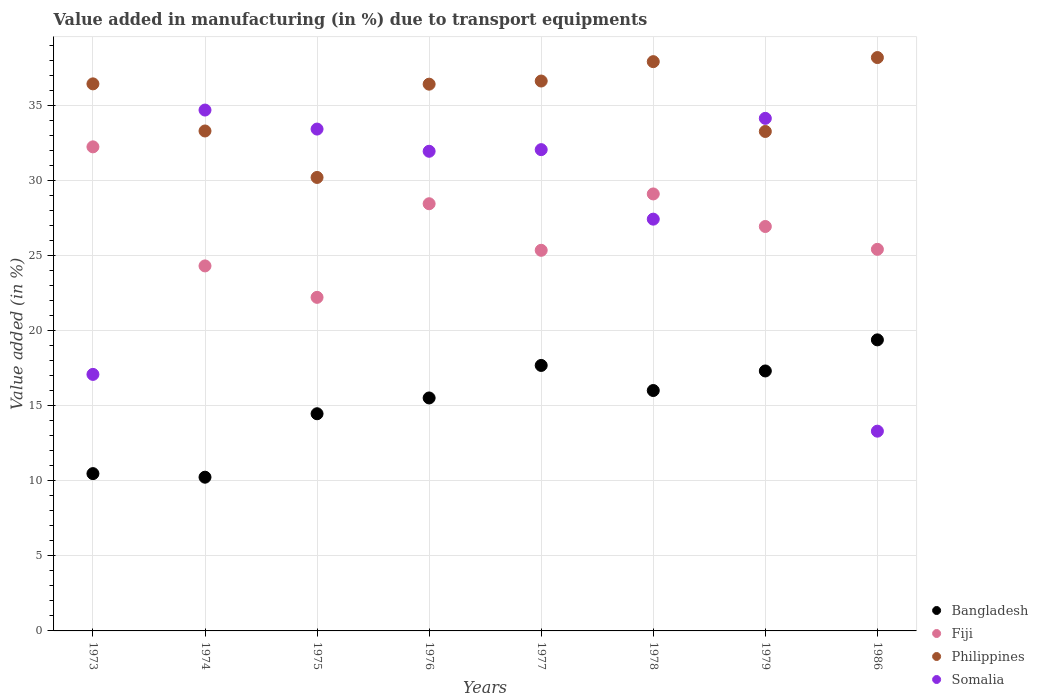How many different coloured dotlines are there?
Provide a succinct answer. 4. Is the number of dotlines equal to the number of legend labels?
Provide a short and direct response. Yes. What is the percentage of value added in manufacturing due to transport equipments in Somalia in 1973?
Your answer should be compact. 17.1. Across all years, what is the maximum percentage of value added in manufacturing due to transport equipments in Somalia?
Your answer should be compact. 34.72. Across all years, what is the minimum percentage of value added in manufacturing due to transport equipments in Philippines?
Provide a succinct answer. 30.23. What is the total percentage of value added in manufacturing due to transport equipments in Fiji in the graph?
Your answer should be compact. 214.19. What is the difference between the percentage of value added in manufacturing due to transport equipments in Somalia in 1973 and that in 1977?
Make the answer very short. -14.98. What is the difference between the percentage of value added in manufacturing due to transport equipments in Somalia in 1975 and the percentage of value added in manufacturing due to transport equipments in Bangladesh in 1976?
Give a very brief answer. 17.92. What is the average percentage of value added in manufacturing due to transport equipments in Philippines per year?
Make the answer very short. 35.32. In the year 1974, what is the difference between the percentage of value added in manufacturing due to transport equipments in Philippines and percentage of value added in manufacturing due to transport equipments in Somalia?
Keep it short and to the point. -1.39. What is the ratio of the percentage of value added in manufacturing due to transport equipments in Somalia in 1975 to that in 1986?
Your answer should be very brief. 2.51. Is the difference between the percentage of value added in manufacturing due to transport equipments in Philippines in 1973 and 1979 greater than the difference between the percentage of value added in manufacturing due to transport equipments in Somalia in 1973 and 1979?
Keep it short and to the point. Yes. What is the difference between the highest and the second highest percentage of value added in manufacturing due to transport equipments in Philippines?
Offer a very short reply. 0.27. What is the difference between the highest and the lowest percentage of value added in manufacturing due to transport equipments in Philippines?
Your response must be concise. 7.99. How many dotlines are there?
Provide a succinct answer. 4. What is the difference between two consecutive major ticks on the Y-axis?
Keep it short and to the point. 5. Are the values on the major ticks of Y-axis written in scientific E-notation?
Your answer should be compact. No. Does the graph contain any zero values?
Offer a terse response. No. Does the graph contain grids?
Your answer should be compact. Yes. Where does the legend appear in the graph?
Provide a short and direct response. Bottom right. How many legend labels are there?
Your response must be concise. 4. How are the legend labels stacked?
Make the answer very short. Vertical. What is the title of the graph?
Your answer should be compact. Value added in manufacturing (in %) due to transport equipments. Does "East Asia (developing only)" appear as one of the legend labels in the graph?
Offer a very short reply. No. What is the label or title of the Y-axis?
Give a very brief answer. Value added (in %). What is the Value added (in %) in Bangladesh in 1973?
Your response must be concise. 10.48. What is the Value added (in %) in Fiji in 1973?
Provide a short and direct response. 32.26. What is the Value added (in %) of Philippines in 1973?
Offer a terse response. 36.46. What is the Value added (in %) in Somalia in 1973?
Make the answer very short. 17.1. What is the Value added (in %) in Bangladesh in 1974?
Offer a terse response. 10.25. What is the Value added (in %) in Fiji in 1974?
Provide a short and direct response. 24.33. What is the Value added (in %) of Philippines in 1974?
Keep it short and to the point. 33.32. What is the Value added (in %) of Somalia in 1974?
Offer a terse response. 34.72. What is the Value added (in %) of Bangladesh in 1975?
Offer a very short reply. 14.48. What is the Value added (in %) in Fiji in 1975?
Your answer should be compact. 22.23. What is the Value added (in %) of Philippines in 1975?
Offer a very short reply. 30.23. What is the Value added (in %) in Somalia in 1975?
Your answer should be very brief. 33.45. What is the Value added (in %) in Bangladesh in 1976?
Make the answer very short. 15.53. What is the Value added (in %) of Fiji in 1976?
Make the answer very short. 28.47. What is the Value added (in %) in Philippines in 1976?
Your answer should be very brief. 36.44. What is the Value added (in %) of Somalia in 1976?
Give a very brief answer. 31.97. What is the Value added (in %) in Bangladesh in 1977?
Your answer should be very brief. 17.7. What is the Value added (in %) of Fiji in 1977?
Provide a short and direct response. 25.37. What is the Value added (in %) of Philippines in 1977?
Keep it short and to the point. 36.65. What is the Value added (in %) of Somalia in 1977?
Make the answer very short. 32.08. What is the Value added (in %) in Bangladesh in 1978?
Ensure brevity in your answer.  16.02. What is the Value added (in %) in Fiji in 1978?
Ensure brevity in your answer.  29.13. What is the Value added (in %) of Philippines in 1978?
Offer a terse response. 37.94. What is the Value added (in %) of Somalia in 1978?
Keep it short and to the point. 27.45. What is the Value added (in %) in Bangladesh in 1979?
Your answer should be compact. 17.33. What is the Value added (in %) of Fiji in 1979?
Your response must be concise. 26.96. What is the Value added (in %) in Philippines in 1979?
Make the answer very short. 33.29. What is the Value added (in %) in Somalia in 1979?
Give a very brief answer. 34.16. What is the Value added (in %) in Bangladesh in 1986?
Ensure brevity in your answer.  19.4. What is the Value added (in %) of Fiji in 1986?
Ensure brevity in your answer.  25.43. What is the Value added (in %) of Philippines in 1986?
Offer a very short reply. 38.22. What is the Value added (in %) in Somalia in 1986?
Offer a terse response. 13.31. Across all years, what is the maximum Value added (in %) of Bangladesh?
Keep it short and to the point. 19.4. Across all years, what is the maximum Value added (in %) in Fiji?
Your answer should be compact. 32.26. Across all years, what is the maximum Value added (in %) in Philippines?
Offer a terse response. 38.22. Across all years, what is the maximum Value added (in %) of Somalia?
Your answer should be compact. 34.72. Across all years, what is the minimum Value added (in %) in Bangladesh?
Your answer should be compact. 10.25. Across all years, what is the minimum Value added (in %) in Fiji?
Ensure brevity in your answer.  22.23. Across all years, what is the minimum Value added (in %) in Philippines?
Give a very brief answer. 30.23. Across all years, what is the minimum Value added (in %) in Somalia?
Offer a terse response. 13.31. What is the total Value added (in %) of Bangladesh in the graph?
Ensure brevity in your answer.  121.18. What is the total Value added (in %) of Fiji in the graph?
Ensure brevity in your answer.  214.19. What is the total Value added (in %) of Philippines in the graph?
Offer a very short reply. 282.56. What is the total Value added (in %) in Somalia in the graph?
Provide a succinct answer. 224.24. What is the difference between the Value added (in %) of Bangladesh in 1973 and that in 1974?
Offer a very short reply. 0.24. What is the difference between the Value added (in %) in Fiji in 1973 and that in 1974?
Keep it short and to the point. 7.94. What is the difference between the Value added (in %) of Philippines in 1973 and that in 1974?
Give a very brief answer. 3.14. What is the difference between the Value added (in %) in Somalia in 1973 and that in 1974?
Keep it short and to the point. -17.62. What is the difference between the Value added (in %) in Bangladesh in 1973 and that in 1975?
Provide a succinct answer. -3.99. What is the difference between the Value added (in %) in Fiji in 1973 and that in 1975?
Provide a succinct answer. 10.03. What is the difference between the Value added (in %) in Philippines in 1973 and that in 1975?
Offer a terse response. 6.24. What is the difference between the Value added (in %) in Somalia in 1973 and that in 1975?
Offer a terse response. -16.35. What is the difference between the Value added (in %) of Bangladesh in 1973 and that in 1976?
Give a very brief answer. -5.04. What is the difference between the Value added (in %) in Fiji in 1973 and that in 1976?
Make the answer very short. 3.79. What is the difference between the Value added (in %) of Philippines in 1973 and that in 1976?
Provide a short and direct response. 0.02. What is the difference between the Value added (in %) in Somalia in 1973 and that in 1976?
Your answer should be compact. -14.87. What is the difference between the Value added (in %) in Bangladesh in 1973 and that in 1977?
Offer a very short reply. -7.21. What is the difference between the Value added (in %) of Fiji in 1973 and that in 1977?
Ensure brevity in your answer.  6.9. What is the difference between the Value added (in %) in Philippines in 1973 and that in 1977?
Offer a very short reply. -0.19. What is the difference between the Value added (in %) of Somalia in 1973 and that in 1977?
Keep it short and to the point. -14.98. What is the difference between the Value added (in %) in Bangladesh in 1973 and that in 1978?
Make the answer very short. -5.54. What is the difference between the Value added (in %) of Fiji in 1973 and that in 1978?
Give a very brief answer. 3.14. What is the difference between the Value added (in %) in Philippines in 1973 and that in 1978?
Your answer should be very brief. -1.48. What is the difference between the Value added (in %) in Somalia in 1973 and that in 1978?
Your answer should be compact. -10.35. What is the difference between the Value added (in %) of Bangladesh in 1973 and that in 1979?
Keep it short and to the point. -6.84. What is the difference between the Value added (in %) of Fiji in 1973 and that in 1979?
Keep it short and to the point. 5.31. What is the difference between the Value added (in %) of Philippines in 1973 and that in 1979?
Your answer should be very brief. 3.17. What is the difference between the Value added (in %) of Somalia in 1973 and that in 1979?
Keep it short and to the point. -17.07. What is the difference between the Value added (in %) in Bangladesh in 1973 and that in 1986?
Offer a very short reply. -8.92. What is the difference between the Value added (in %) of Fiji in 1973 and that in 1986?
Offer a very short reply. 6.83. What is the difference between the Value added (in %) in Philippines in 1973 and that in 1986?
Provide a short and direct response. -1.75. What is the difference between the Value added (in %) in Somalia in 1973 and that in 1986?
Your answer should be very brief. 3.78. What is the difference between the Value added (in %) of Bangladesh in 1974 and that in 1975?
Give a very brief answer. -4.23. What is the difference between the Value added (in %) of Fiji in 1974 and that in 1975?
Offer a very short reply. 2.1. What is the difference between the Value added (in %) of Philippines in 1974 and that in 1975?
Provide a short and direct response. 3.1. What is the difference between the Value added (in %) of Somalia in 1974 and that in 1975?
Provide a succinct answer. 1.27. What is the difference between the Value added (in %) in Bangladesh in 1974 and that in 1976?
Give a very brief answer. -5.28. What is the difference between the Value added (in %) in Fiji in 1974 and that in 1976?
Provide a succinct answer. -4.14. What is the difference between the Value added (in %) of Philippines in 1974 and that in 1976?
Make the answer very short. -3.12. What is the difference between the Value added (in %) in Somalia in 1974 and that in 1976?
Keep it short and to the point. 2.75. What is the difference between the Value added (in %) in Bangladesh in 1974 and that in 1977?
Keep it short and to the point. -7.45. What is the difference between the Value added (in %) in Fiji in 1974 and that in 1977?
Your answer should be very brief. -1.04. What is the difference between the Value added (in %) of Philippines in 1974 and that in 1977?
Your answer should be very brief. -3.33. What is the difference between the Value added (in %) in Somalia in 1974 and that in 1977?
Offer a very short reply. 2.64. What is the difference between the Value added (in %) in Bangladesh in 1974 and that in 1978?
Give a very brief answer. -5.78. What is the difference between the Value added (in %) in Fiji in 1974 and that in 1978?
Give a very brief answer. -4.8. What is the difference between the Value added (in %) of Philippines in 1974 and that in 1978?
Keep it short and to the point. -4.62. What is the difference between the Value added (in %) of Somalia in 1974 and that in 1978?
Your answer should be very brief. 7.27. What is the difference between the Value added (in %) in Bangladesh in 1974 and that in 1979?
Your answer should be compact. -7.08. What is the difference between the Value added (in %) in Fiji in 1974 and that in 1979?
Ensure brevity in your answer.  -2.63. What is the difference between the Value added (in %) in Philippines in 1974 and that in 1979?
Offer a very short reply. 0.03. What is the difference between the Value added (in %) in Somalia in 1974 and that in 1979?
Your answer should be very brief. 0.55. What is the difference between the Value added (in %) of Bangladesh in 1974 and that in 1986?
Your answer should be compact. -9.15. What is the difference between the Value added (in %) of Fiji in 1974 and that in 1986?
Your answer should be compact. -1.11. What is the difference between the Value added (in %) in Philippines in 1974 and that in 1986?
Your response must be concise. -4.89. What is the difference between the Value added (in %) in Somalia in 1974 and that in 1986?
Offer a terse response. 21.4. What is the difference between the Value added (in %) in Bangladesh in 1975 and that in 1976?
Give a very brief answer. -1.05. What is the difference between the Value added (in %) in Fiji in 1975 and that in 1976?
Ensure brevity in your answer.  -6.24. What is the difference between the Value added (in %) of Philippines in 1975 and that in 1976?
Offer a very short reply. -6.22. What is the difference between the Value added (in %) in Somalia in 1975 and that in 1976?
Provide a succinct answer. 1.48. What is the difference between the Value added (in %) in Bangladesh in 1975 and that in 1977?
Ensure brevity in your answer.  -3.22. What is the difference between the Value added (in %) of Fiji in 1975 and that in 1977?
Provide a succinct answer. -3.14. What is the difference between the Value added (in %) in Philippines in 1975 and that in 1977?
Give a very brief answer. -6.43. What is the difference between the Value added (in %) of Somalia in 1975 and that in 1977?
Offer a very short reply. 1.37. What is the difference between the Value added (in %) in Bangladesh in 1975 and that in 1978?
Ensure brevity in your answer.  -1.55. What is the difference between the Value added (in %) in Fiji in 1975 and that in 1978?
Ensure brevity in your answer.  -6.89. What is the difference between the Value added (in %) of Philippines in 1975 and that in 1978?
Your response must be concise. -7.72. What is the difference between the Value added (in %) of Somalia in 1975 and that in 1978?
Give a very brief answer. 6. What is the difference between the Value added (in %) of Bangladesh in 1975 and that in 1979?
Provide a short and direct response. -2.85. What is the difference between the Value added (in %) in Fiji in 1975 and that in 1979?
Provide a succinct answer. -4.72. What is the difference between the Value added (in %) of Philippines in 1975 and that in 1979?
Your answer should be very brief. -3.06. What is the difference between the Value added (in %) in Somalia in 1975 and that in 1979?
Ensure brevity in your answer.  -0.71. What is the difference between the Value added (in %) of Bangladesh in 1975 and that in 1986?
Your answer should be compact. -4.92. What is the difference between the Value added (in %) in Fiji in 1975 and that in 1986?
Make the answer very short. -3.2. What is the difference between the Value added (in %) in Philippines in 1975 and that in 1986?
Keep it short and to the point. -7.99. What is the difference between the Value added (in %) in Somalia in 1975 and that in 1986?
Your answer should be compact. 20.14. What is the difference between the Value added (in %) in Bangladesh in 1976 and that in 1977?
Keep it short and to the point. -2.17. What is the difference between the Value added (in %) of Fiji in 1976 and that in 1977?
Give a very brief answer. 3.1. What is the difference between the Value added (in %) of Philippines in 1976 and that in 1977?
Your answer should be very brief. -0.21. What is the difference between the Value added (in %) of Somalia in 1976 and that in 1977?
Provide a succinct answer. -0.11. What is the difference between the Value added (in %) in Bangladesh in 1976 and that in 1978?
Your response must be concise. -0.5. What is the difference between the Value added (in %) of Fiji in 1976 and that in 1978?
Give a very brief answer. -0.65. What is the difference between the Value added (in %) of Philippines in 1976 and that in 1978?
Provide a succinct answer. -1.5. What is the difference between the Value added (in %) in Somalia in 1976 and that in 1978?
Provide a short and direct response. 4.52. What is the difference between the Value added (in %) in Bangladesh in 1976 and that in 1979?
Make the answer very short. -1.8. What is the difference between the Value added (in %) in Fiji in 1976 and that in 1979?
Give a very brief answer. 1.52. What is the difference between the Value added (in %) of Philippines in 1976 and that in 1979?
Give a very brief answer. 3.15. What is the difference between the Value added (in %) in Somalia in 1976 and that in 1979?
Offer a terse response. -2.19. What is the difference between the Value added (in %) in Bangladesh in 1976 and that in 1986?
Offer a terse response. -3.87. What is the difference between the Value added (in %) in Fiji in 1976 and that in 1986?
Ensure brevity in your answer.  3.04. What is the difference between the Value added (in %) in Philippines in 1976 and that in 1986?
Keep it short and to the point. -1.77. What is the difference between the Value added (in %) in Somalia in 1976 and that in 1986?
Offer a terse response. 18.66. What is the difference between the Value added (in %) of Bangladesh in 1977 and that in 1978?
Your answer should be compact. 1.67. What is the difference between the Value added (in %) of Fiji in 1977 and that in 1978?
Keep it short and to the point. -3.76. What is the difference between the Value added (in %) of Philippines in 1977 and that in 1978?
Make the answer very short. -1.29. What is the difference between the Value added (in %) of Somalia in 1977 and that in 1978?
Keep it short and to the point. 4.63. What is the difference between the Value added (in %) in Bangladesh in 1977 and that in 1979?
Ensure brevity in your answer.  0.37. What is the difference between the Value added (in %) of Fiji in 1977 and that in 1979?
Offer a terse response. -1.59. What is the difference between the Value added (in %) of Philippines in 1977 and that in 1979?
Offer a very short reply. 3.36. What is the difference between the Value added (in %) in Somalia in 1977 and that in 1979?
Provide a short and direct response. -2.09. What is the difference between the Value added (in %) of Bangladesh in 1977 and that in 1986?
Your response must be concise. -1.7. What is the difference between the Value added (in %) of Fiji in 1977 and that in 1986?
Give a very brief answer. -0.07. What is the difference between the Value added (in %) in Philippines in 1977 and that in 1986?
Your answer should be very brief. -1.56. What is the difference between the Value added (in %) of Somalia in 1977 and that in 1986?
Give a very brief answer. 18.77. What is the difference between the Value added (in %) in Bangladesh in 1978 and that in 1979?
Your answer should be compact. -1.3. What is the difference between the Value added (in %) in Fiji in 1978 and that in 1979?
Your answer should be very brief. 2.17. What is the difference between the Value added (in %) of Philippines in 1978 and that in 1979?
Ensure brevity in your answer.  4.65. What is the difference between the Value added (in %) of Somalia in 1978 and that in 1979?
Your answer should be compact. -6.72. What is the difference between the Value added (in %) in Bangladesh in 1978 and that in 1986?
Your answer should be compact. -3.38. What is the difference between the Value added (in %) in Fiji in 1978 and that in 1986?
Make the answer very short. 3.69. What is the difference between the Value added (in %) in Philippines in 1978 and that in 1986?
Your answer should be compact. -0.27. What is the difference between the Value added (in %) of Somalia in 1978 and that in 1986?
Ensure brevity in your answer.  14.13. What is the difference between the Value added (in %) of Bangladesh in 1979 and that in 1986?
Your response must be concise. -2.07. What is the difference between the Value added (in %) of Fiji in 1979 and that in 1986?
Offer a very short reply. 1.52. What is the difference between the Value added (in %) of Philippines in 1979 and that in 1986?
Offer a very short reply. -4.93. What is the difference between the Value added (in %) in Somalia in 1979 and that in 1986?
Provide a short and direct response. 20.85. What is the difference between the Value added (in %) in Bangladesh in 1973 and the Value added (in %) in Fiji in 1974?
Your response must be concise. -13.84. What is the difference between the Value added (in %) in Bangladesh in 1973 and the Value added (in %) in Philippines in 1974?
Provide a short and direct response. -22.84. What is the difference between the Value added (in %) of Bangladesh in 1973 and the Value added (in %) of Somalia in 1974?
Ensure brevity in your answer.  -24.23. What is the difference between the Value added (in %) of Fiji in 1973 and the Value added (in %) of Philippines in 1974?
Offer a terse response. -1.06. What is the difference between the Value added (in %) of Fiji in 1973 and the Value added (in %) of Somalia in 1974?
Keep it short and to the point. -2.45. What is the difference between the Value added (in %) in Philippines in 1973 and the Value added (in %) in Somalia in 1974?
Offer a very short reply. 1.75. What is the difference between the Value added (in %) of Bangladesh in 1973 and the Value added (in %) of Fiji in 1975?
Offer a terse response. -11.75. What is the difference between the Value added (in %) in Bangladesh in 1973 and the Value added (in %) in Philippines in 1975?
Offer a terse response. -19.74. What is the difference between the Value added (in %) in Bangladesh in 1973 and the Value added (in %) in Somalia in 1975?
Ensure brevity in your answer.  -22.97. What is the difference between the Value added (in %) in Fiji in 1973 and the Value added (in %) in Philippines in 1975?
Provide a succinct answer. 2.04. What is the difference between the Value added (in %) in Fiji in 1973 and the Value added (in %) in Somalia in 1975?
Keep it short and to the point. -1.19. What is the difference between the Value added (in %) of Philippines in 1973 and the Value added (in %) of Somalia in 1975?
Your answer should be compact. 3.01. What is the difference between the Value added (in %) of Bangladesh in 1973 and the Value added (in %) of Fiji in 1976?
Keep it short and to the point. -17.99. What is the difference between the Value added (in %) in Bangladesh in 1973 and the Value added (in %) in Philippines in 1976?
Your answer should be very brief. -25.96. What is the difference between the Value added (in %) in Bangladesh in 1973 and the Value added (in %) in Somalia in 1976?
Your response must be concise. -21.49. What is the difference between the Value added (in %) of Fiji in 1973 and the Value added (in %) of Philippines in 1976?
Ensure brevity in your answer.  -4.18. What is the difference between the Value added (in %) in Fiji in 1973 and the Value added (in %) in Somalia in 1976?
Your response must be concise. 0.29. What is the difference between the Value added (in %) of Philippines in 1973 and the Value added (in %) of Somalia in 1976?
Ensure brevity in your answer.  4.49. What is the difference between the Value added (in %) of Bangladesh in 1973 and the Value added (in %) of Fiji in 1977?
Offer a terse response. -14.88. What is the difference between the Value added (in %) in Bangladesh in 1973 and the Value added (in %) in Philippines in 1977?
Offer a very short reply. -26.17. What is the difference between the Value added (in %) of Bangladesh in 1973 and the Value added (in %) of Somalia in 1977?
Your answer should be very brief. -21.59. What is the difference between the Value added (in %) of Fiji in 1973 and the Value added (in %) of Philippines in 1977?
Your answer should be very brief. -4.39. What is the difference between the Value added (in %) of Fiji in 1973 and the Value added (in %) of Somalia in 1977?
Your response must be concise. 0.19. What is the difference between the Value added (in %) of Philippines in 1973 and the Value added (in %) of Somalia in 1977?
Offer a terse response. 4.38. What is the difference between the Value added (in %) of Bangladesh in 1973 and the Value added (in %) of Fiji in 1978?
Provide a short and direct response. -18.64. What is the difference between the Value added (in %) in Bangladesh in 1973 and the Value added (in %) in Philippines in 1978?
Keep it short and to the point. -27.46. What is the difference between the Value added (in %) of Bangladesh in 1973 and the Value added (in %) of Somalia in 1978?
Your answer should be very brief. -16.96. What is the difference between the Value added (in %) of Fiji in 1973 and the Value added (in %) of Philippines in 1978?
Ensure brevity in your answer.  -5.68. What is the difference between the Value added (in %) of Fiji in 1973 and the Value added (in %) of Somalia in 1978?
Give a very brief answer. 4.82. What is the difference between the Value added (in %) in Philippines in 1973 and the Value added (in %) in Somalia in 1978?
Provide a short and direct response. 9.02. What is the difference between the Value added (in %) of Bangladesh in 1973 and the Value added (in %) of Fiji in 1979?
Your response must be concise. -16.47. What is the difference between the Value added (in %) of Bangladesh in 1973 and the Value added (in %) of Philippines in 1979?
Offer a terse response. -22.81. What is the difference between the Value added (in %) of Bangladesh in 1973 and the Value added (in %) of Somalia in 1979?
Make the answer very short. -23.68. What is the difference between the Value added (in %) in Fiji in 1973 and the Value added (in %) in Philippines in 1979?
Ensure brevity in your answer.  -1.03. What is the difference between the Value added (in %) in Fiji in 1973 and the Value added (in %) in Somalia in 1979?
Keep it short and to the point. -1.9. What is the difference between the Value added (in %) in Philippines in 1973 and the Value added (in %) in Somalia in 1979?
Keep it short and to the point. 2.3. What is the difference between the Value added (in %) of Bangladesh in 1973 and the Value added (in %) of Fiji in 1986?
Your answer should be very brief. -14.95. What is the difference between the Value added (in %) of Bangladesh in 1973 and the Value added (in %) of Philippines in 1986?
Offer a very short reply. -27.73. What is the difference between the Value added (in %) in Bangladesh in 1973 and the Value added (in %) in Somalia in 1986?
Ensure brevity in your answer.  -2.83. What is the difference between the Value added (in %) of Fiji in 1973 and the Value added (in %) of Philippines in 1986?
Ensure brevity in your answer.  -5.95. What is the difference between the Value added (in %) in Fiji in 1973 and the Value added (in %) in Somalia in 1986?
Provide a short and direct response. 18.95. What is the difference between the Value added (in %) in Philippines in 1973 and the Value added (in %) in Somalia in 1986?
Give a very brief answer. 23.15. What is the difference between the Value added (in %) of Bangladesh in 1974 and the Value added (in %) of Fiji in 1975?
Your response must be concise. -11.99. What is the difference between the Value added (in %) in Bangladesh in 1974 and the Value added (in %) in Philippines in 1975?
Make the answer very short. -19.98. What is the difference between the Value added (in %) in Bangladesh in 1974 and the Value added (in %) in Somalia in 1975?
Keep it short and to the point. -23.2. What is the difference between the Value added (in %) of Fiji in 1974 and the Value added (in %) of Philippines in 1975?
Offer a terse response. -5.9. What is the difference between the Value added (in %) in Fiji in 1974 and the Value added (in %) in Somalia in 1975?
Offer a terse response. -9.12. What is the difference between the Value added (in %) of Philippines in 1974 and the Value added (in %) of Somalia in 1975?
Offer a very short reply. -0.13. What is the difference between the Value added (in %) in Bangladesh in 1974 and the Value added (in %) in Fiji in 1976?
Keep it short and to the point. -18.23. What is the difference between the Value added (in %) in Bangladesh in 1974 and the Value added (in %) in Philippines in 1976?
Make the answer very short. -26.2. What is the difference between the Value added (in %) of Bangladesh in 1974 and the Value added (in %) of Somalia in 1976?
Your answer should be compact. -21.72. What is the difference between the Value added (in %) of Fiji in 1974 and the Value added (in %) of Philippines in 1976?
Give a very brief answer. -12.11. What is the difference between the Value added (in %) in Fiji in 1974 and the Value added (in %) in Somalia in 1976?
Your response must be concise. -7.64. What is the difference between the Value added (in %) in Philippines in 1974 and the Value added (in %) in Somalia in 1976?
Provide a succinct answer. 1.35. What is the difference between the Value added (in %) of Bangladesh in 1974 and the Value added (in %) of Fiji in 1977?
Your answer should be compact. -15.12. What is the difference between the Value added (in %) in Bangladesh in 1974 and the Value added (in %) in Philippines in 1977?
Ensure brevity in your answer.  -26.41. What is the difference between the Value added (in %) in Bangladesh in 1974 and the Value added (in %) in Somalia in 1977?
Make the answer very short. -21.83. What is the difference between the Value added (in %) of Fiji in 1974 and the Value added (in %) of Philippines in 1977?
Ensure brevity in your answer.  -12.32. What is the difference between the Value added (in %) of Fiji in 1974 and the Value added (in %) of Somalia in 1977?
Your response must be concise. -7.75. What is the difference between the Value added (in %) in Philippines in 1974 and the Value added (in %) in Somalia in 1977?
Offer a very short reply. 1.24. What is the difference between the Value added (in %) in Bangladesh in 1974 and the Value added (in %) in Fiji in 1978?
Make the answer very short. -18.88. What is the difference between the Value added (in %) in Bangladesh in 1974 and the Value added (in %) in Philippines in 1978?
Ensure brevity in your answer.  -27.7. What is the difference between the Value added (in %) of Bangladesh in 1974 and the Value added (in %) of Somalia in 1978?
Your answer should be very brief. -17.2. What is the difference between the Value added (in %) in Fiji in 1974 and the Value added (in %) in Philippines in 1978?
Make the answer very short. -13.61. What is the difference between the Value added (in %) in Fiji in 1974 and the Value added (in %) in Somalia in 1978?
Provide a succinct answer. -3.12. What is the difference between the Value added (in %) of Philippines in 1974 and the Value added (in %) of Somalia in 1978?
Your response must be concise. 5.88. What is the difference between the Value added (in %) in Bangladesh in 1974 and the Value added (in %) in Fiji in 1979?
Keep it short and to the point. -16.71. What is the difference between the Value added (in %) in Bangladesh in 1974 and the Value added (in %) in Philippines in 1979?
Your answer should be compact. -23.04. What is the difference between the Value added (in %) in Bangladesh in 1974 and the Value added (in %) in Somalia in 1979?
Offer a terse response. -23.92. What is the difference between the Value added (in %) of Fiji in 1974 and the Value added (in %) of Philippines in 1979?
Make the answer very short. -8.96. What is the difference between the Value added (in %) in Fiji in 1974 and the Value added (in %) in Somalia in 1979?
Ensure brevity in your answer.  -9.84. What is the difference between the Value added (in %) in Philippines in 1974 and the Value added (in %) in Somalia in 1979?
Offer a terse response. -0.84. What is the difference between the Value added (in %) in Bangladesh in 1974 and the Value added (in %) in Fiji in 1986?
Provide a short and direct response. -15.19. What is the difference between the Value added (in %) in Bangladesh in 1974 and the Value added (in %) in Philippines in 1986?
Provide a short and direct response. -27.97. What is the difference between the Value added (in %) of Bangladesh in 1974 and the Value added (in %) of Somalia in 1986?
Offer a very short reply. -3.07. What is the difference between the Value added (in %) in Fiji in 1974 and the Value added (in %) in Philippines in 1986?
Your answer should be compact. -13.89. What is the difference between the Value added (in %) in Fiji in 1974 and the Value added (in %) in Somalia in 1986?
Give a very brief answer. 11.02. What is the difference between the Value added (in %) in Philippines in 1974 and the Value added (in %) in Somalia in 1986?
Your answer should be very brief. 20.01. What is the difference between the Value added (in %) in Bangladesh in 1975 and the Value added (in %) in Fiji in 1976?
Provide a short and direct response. -14. What is the difference between the Value added (in %) in Bangladesh in 1975 and the Value added (in %) in Philippines in 1976?
Offer a terse response. -21.97. What is the difference between the Value added (in %) in Bangladesh in 1975 and the Value added (in %) in Somalia in 1976?
Make the answer very short. -17.49. What is the difference between the Value added (in %) of Fiji in 1975 and the Value added (in %) of Philippines in 1976?
Provide a short and direct response. -14.21. What is the difference between the Value added (in %) of Fiji in 1975 and the Value added (in %) of Somalia in 1976?
Offer a very short reply. -9.74. What is the difference between the Value added (in %) in Philippines in 1975 and the Value added (in %) in Somalia in 1976?
Give a very brief answer. -1.74. What is the difference between the Value added (in %) in Bangladesh in 1975 and the Value added (in %) in Fiji in 1977?
Keep it short and to the point. -10.89. What is the difference between the Value added (in %) in Bangladesh in 1975 and the Value added (in %) in Philippines in 1977?
Your answer should be compact. -22.18. What is the difference between the Value added (in %) of Bangladesh in 1975 and the Value added (in %) of Somalia in 1977?
Provide a succinct answer. -17.6. What is the difference between the Value added (in %) of Fiji in 1975 and the Value added (in %) of Philippines in 1977?
Keep it short and to the point. -14.42. What is the difference between the Value added (in %) of Fiji in 1975 and the Value added (in %) of Somalia in 1977?
Your answer should be very brief. -9.85. What is the difference between the Value added (in %) of Philippines in 1975 and the Value added (in %) of Somalia in 1977?
Make the answer very short. -1.85. What is the difference between the Value added (in %) in Bangladesh in 1975 and the Value added (in %) in Fiji in 1978?
Your answer should be compact. -14.65. What is the difference between the Value added (in %) of Bangladesh in 1975 and the Value added (in %) of Philippines in 1978?
Keep it short and to the point. -23.47. What is the difference between the Value added (in %) of Bangladesh in 1975 and the Value added (in %) of Somalia in 1978?
Offer a terse response. -12.97. What is the difference between the Value added (in %) in Fiji in 1975 and the Value added (in %) in Philippines in 1978?
Provide a short and direct response. -15.71. What is the difference between the Value added (in %) of Fiji in 1975 and the Value added (in %) of Somalia in 1978?
Offer a terse response. -5.21. What is the difference between the Value added (in %) in Philippines in 1975 and the Value added (in %) in Somalia in 1978?
Your response must be concise. 2.78. What is the difference between the Value added (in %) of Bangladesh in 1975 and the Value added (in %) of Fiji in 1979?
Offer a very short reply. -12.48. What is the difference between the Value added (in %) in Bangladesh in 1975 and the Value added (in %) in Philippines in 1979?
Your answer should be very brief. -18.82. What is the difference between the Value added (in %) of Bangladesh in 1975 and the Value added (in %) of Somalia in 1979?
Your answer should be compact. -19.69. What is the difference between the Value added (in %) in Fiji in 1975 and the Value added (in %) in Philippines in 1979?
Give a very brief answer. -11.06. What is the difference between the Value added (in %) of Fiji in 1975 and the Value added (in %) of Somalia in 1979?
Your response must be concise. -11.93. What is the difference between the Value added (in %) of Philippines in 1975 and the Value added (in %) of Somalia in 1979?
Make the answer very short. -3.94. What is the difference between the Value added (in %) in Bangladesh in 1975 and the Value added (in %) in Fiji in 1986?
Your response must be concise. -10.96. What is the difference between the Value added (in %) in Bangladesh in 1975 and the Value added (in %) in Philippines in 1986?
Offer a very short reply. -23.74. What is the difference between the Value added (in %) of Bangladesh in 1975 and the Value added (in %) of Somalia in 1986?
Keep it short and to the point. 1.16. What is the difference between the Value added (in %) of Fiji in 1975 and the Value added (in %) of Philippines in 1986?
Provide a short and direct response. -15.98. What is the difference between the Value added (in %) of Fiji in 1975 and the Value added (in %) of Somalia in 1986?
Keep it short and to the point. 8.92. What is the difference between the Value added (in %) of Philippines in 1975 and the Value added (in %) of Somalia in 1986?
Keep it short and to the point. 16.91. What is the difference between the Value added (in %) of Bangladesh in 1976 and the Value added (in %) of Fiji in 1977?
Your response must be concise. -9.84. What is the difference between the Value added (in %) of Bangladesh in 1976 and the Value added (in %) of Philippines in 1977?
Make the answer very short. -21.12. What is the difference between the Value added (in %) of Bangladesh in 1976 and the Value added (in %) of Somalia in 1977?
Provide a succinct answer. -16.55. What is the difference between the Value added (in %) of Fiji in 1976 and the Value added (in %) of Philippines in 1977?
Offer a terse response. -8.18. What is the difference between the Value added (in %) in Fiji in 1976 and the Value added (in %) in Somalia in 1977?
Provide a short and direct response. -3.61. What is the difference between the Value added (in %) in Philippines in 1976 and the Value added (in %) in Somalia in 1977?
Your response must be concise. 4.36. What is the difference between the Value added (in %) of Bangladesh in 1976 and the Value added (in %) of Fiji in 1978?
Your answer should be very brief. -13.6. What is the difference between the Value added (in %) in Bangladesh in 1976 and the Value added (in %) in Philippines in 1978?
Your answer should be very brief. -22.42. What is the difference between the Value added (in %) of Bangladesh in 1976 and the Value added (in %) of Somalia in 1978?
Ensure brevity in your answer.  -11.92. What is the difference between the Value added (in %) in Fiji in 1976 and the Value added (in %) in Philippines in 1978?
Your answer should be very brief. -9.47. What is the difference between the Value added (in %) of Fiji in 1976 and the Value added (in %) of Somalia in 1978?
Give a very brief answer. 1.03. What is the difference between the Value added (in %) of Philippines in 1976 and the Value added (in %) of Somalia in 1978?
Your answer should be compact. 9. What is the difference between the Value added (in %) in Bangladesh in 1976 and the Value added (in %) in Fiji in 1979?
Provide a succinct answer. -11.43. What is the difference between the Value added (in %) of Bangladesh in 1976 and the Value added (in %) of Philippines in 1979?
Provide a succinct answer. -17.76. What is the difference between the Value added (in %) of Bangladesh in 1976 and the Value added (in %) of Somalia in 1979?
Ensure brevity in your answer.  -18.64. What is the difference between the Value added (in %) in Fiji in 1976 and the Value added (in %) in Philippines in 1979?
Your answer should be compact. -4.82. What is the difference between the Value added (in %) of Fiji in 1976 and the Value added (in %) of Somalia in 1979?
Make the answer very short. -5.69. What is the difference between the Value added (in %) of Philippines in 1976 and the Value added (in %) of Somalia in 1979?
Give a very brief answer. 2.28. What is the difference between the Value added (in %) of Bangladesh in 1976 and the Value added (in %) of Fiji in 1986?
Make the answer very short. -9.91. What is the difference between the Value added (in %) in Bangladesh in 1976 and the Value added (in %) in Philippines in 1986?
Ensure brevity in your answer.  -22.69. What is the difference between the Value added (in %) in Bangladesh in 1976 and the Value added (in %) in Somalia in 1986?
Your answer should be very brief. 2.21. What is the difference between the Value added (in %) in Fiji in 1976 and the Value added (in %) in Philippines in 1986?
Your answer should be very brief. -9.74. What is the difference between the Value added (in %) in Fiji in 1976 and the Value added (in %) in Somalia in 1986?
Your answer should be compact. 15.16. What is the difference between the Value added (in %) in Philippines in 1976 and the Value added (in %) in Somalia in 1986?
Offer a terse response. 23.13. What is the difference between the Value added (in %) in Bangladesh in 1977 and the Value added (in %) in Fiji in 1978?
Ensure brevity in your answer.  -11.43. What is the difference between the Value added (in %) of Bangladesh in 1977 and the Value added (in %) of Philippines in 1978?
Provide a short and direct response. -20.25. What is the difference between the Value added (in %) in Bangladesh in 1977 and the Value added (in %) in Somalia in 1978?
Ensure brevity in your answer.  -9.75. What is the difference between the Value added (in %) of Fiji in 1977 and the Value added (in %) of Philippines in 1978?
Make the answer very short. -12.57. What is the difference between the Value added (in %) in Fiji in 1977 and the Value added (in %) in Somalia in 1978?
Make the answer very short. -2.08. What is the difference between the Value added (in %) in Philippines in 1977 and the Value added (in %) in Somalia in 1978?
Your answer should be compact. 9.21. What is the difference between the Value added (in %) in Bangladesh in 1977 and the Value added (in %) in Fiji in 1979?
Provide a short and direct response. -9.26. What is the difference between the Value added (in %) in Bangladesh in 1977 and the Value added (in %) in Philippines in 1979?
Give a very brief answer. -15.6. What is the difference between the Value added (in %) in Bangladesh in 1977 and the Value added (in %) in Somalia in 1979?
Provide a succinct answer. -16.47. What is the difference between the Value added (in %) in Fiji in 1977 and the Value added (in %) in Philippines in 1979?
Offer a very short reply. -7.92. What is the difference between the Value added (in %) in Fiji in 1977 and the Value added (in %) in Somalia in 1979?
Your response must be concise. -8.79. What is the difference between the Value added (in %) in Philippines in 1977 and the Value added (in %) in Somalia in 1979?
Ensure brevity in your answer.  2.49. What is the difference between the Value added (in %) of Bangladesh in 1977 and the Value added (in %) of Fiji in 1986?
Provide a succinct answer. -7.74. What is the difference between the Value added (in %) in Bangladesh in 1977 and the Value added (in %) in Philippines in 1986?
Give a very brief answer. -20.52. What is the difference between the Value added (in %) in Bangladesh in 1977 and the Value added (in %) in Somalia in 1986?
Your answer should be compact. 4.38. What is the difference between the Value added (in %) of Fiji in 1977 and the Value added (in %) of Philippines in 1986?
Your answer should be compact. -12.85. What is the difference between the Value added (in %) in Fiji in 1977 and the Value added (in %) in Somalia in 1986?
Your response must be concise. 12.06. What is the difference between the Value added (in %) in Philippines in 1977 and the Value added (in %) in Somalia in 1986?
Offer a very short reply. 23.34. What is the difference between the Value added (in %) of Bangladesh in 1978 and the Value added (in %) of Fiji in 1979?
Offer a terse response. -10.93. What is the difference between the Value added (in %) in Bangladesh in 1978 and the Value added (in %) in Philippines in 1979?
Make the answer very short. -17.27. What is the difference between the Value added (in %) in Bangladesh in 1978 and the Value added (in %) in Somalia in 1979?
Offer a terse response. -18.14. What is the difference between the Value added (in %) in Fiji in 1978 and the Value added (in %) in Philippines in 1979?
Your response must be concise. -4.16. What is the difference between the Value added (in %) in Fiji in 1978 and the Value added (in %) in Somalia in 1979?
Your answer should be very brief. -5.04. What is the difference between the Value added (in %) in Philippines in 1978 and the Value added (in %) in Somalia in 1979?
Your answer should be compact. 3.78. What is the difference between the Value added (in %) in Bangladesh in 1978 and the Value added (in %) in Fiji in 1986?
Ensure brevity in your answer.  -9.41. What is the difference between the Value added (in %) in Bangladesh in 1978 and the Value added (in %) in Philippines in 1986?
Provide a succinct answer. -22.19. What is the difference between the Value added (in %) of Bangladesh in 1978 and the Value added (in %) of Somalia in 1986?
Provide a succinct answer. 2.71. What is the difference between the Value added (in %) of Fiji in 1978 and the Value added (in %) of Philippines in 1986?
Offer a terse response. -9.09. What is the difference between the Value added (in %) in Fiji in 1978 and the Value added (in %) in Somalia in 1986?
Your answer should be compact. 15.81. What is the difference between the Value added (in %) of Philippines in 1978 and the Value added (in %) of Somalia in 1986?
Keep it short and to the point. 24.63. What is the difference between the Value added (in %) of Bangladesh in 1979 and the Value added (in %) of Fiji in 1986?
Your answer should be compact. -8.11. What is the difference between the Value added (in %) of Bangladesh in 1979 and the Value added (in %) of Philippines in 1986?
Ensure brevity in your answer.  -20.89. What is the difference between the Value added (in %) in Bangladesh in 1979 and the Value added (in %) in Somalia in 1986?
Provide a succinct answer. 4.01. What is the difference between the Value added (in %) of Fiji in 1979 and the Value added (in %) of Philippines in 1986?
Offer a terse response. -11.26. What is the difference between the Value added (in %) of Fiji in 1979 and the Value added (in %) of Somalia in 1986?
Your response must be concise. 13.64. What is the difference between the Value added (in %) in Philippines in 1979 and the Value added (in %) in Somalia in 1986?
Give a very brief answer. 19.98. What is the average Value added (in %) in Bangladesh per year?
Your response must be concise. 15.15. What is the average Value added (in %) in Fiji per year?
Offer a very short reply. 26.77. What is the average Value added (in %) of Philippines per year?
Give a very brief answer. 35.32. What is the average Value added (in %) of Somalia per year?
Your answer should be very brief. 28.03. In the year 1973, what is the difference between the Value added (in %) in Bangladesh and Value added (in %) in Fiji?
Give a very brief answer. -21.78. In the year 1973, what is the difference between the Value added (in %) in Bangladesh and Value added (in %) in Philippines?
Your response must be concise. -25.98. In the year 1973, what is the difference between the Value added (in %) of Bangladesh and Value added (in %) of Somalia?
Keep it short and to the point. -6.61. In the year 1973, what is the difference between the Value added (in %) of Fiji and Value added (in %) of Philippines?
Keep it short and to the point. -4.2. In the year 1973, what is the difference between the Value added (in %) in Fiji and Value added (in %) in Somalia?
Your answer should be compact. 15.17. In the year 1973, what is the difference between the Value added (in %) of Philippines and Value added (in %) of Somalia?
Offer a very short reply. 19.36. In the year 1974, what is the difference between the Value added (in %) of Bangladesh and Value added (in %) of Fiji?
Offer a very short reply. -14.08. In the year 1974, what is the difference between the Value added (in %) in Bangladesh and Value added (in %) in Philippines?
Your answer should be very brief. -23.08. In the year 1974, what is the difference between the Value added (in %) of Bangladesh and Value added (in %) of Somalia?
Provide a short and direct response. -24.47. In the year 1974, what is the difference between the Value added (in %) of Fiji and Value added (in %) of Philippines?
Ensure brevity in your answer.  -8.99. In the year 1974, what is the difference between the Value added (in %) in Fiji and Value added (in %) in Somalia?
Keep it short and to the point. -10.39. In the year 1974, what is the difference between the Value added (in %) of Philippines and Value added (in %) of Somalia?
Make the answer very short. -1.39. In the year 1975, what is the difference between the Value added (in %) in Bangladesh and Value added (in %) in Fiji?
Offer a very short reply. -7.76. In the year 1975, what is the difference between the Value added (in %) of Bangladesh and Value added (in %) of Philippines?
Make the answer very short. -15.75. In the year 1975, what is the difference between the Value added (in %) of Bangladesh and Value added (in %) of Somalia?
Provide a succinct answer. -18.97. In the year 1975, what is the difference between the Value added (in %) of Fiji and Value added (in %) of Philippines?
Ensure brevity in your answer.  -7.99. In the year 1975, what is the difference between the Value added (in %) of Fiji and Value added (in %) of Somalia?
Your answer should be compact. -11.22. In the year 1975, what is the difference between the Value added (in %) of Philippines and Value added (in %) of Somalia?
Keep it short and to the point. -3.22. In the year 1976, what is the difference between the Value added (in %) of Bangladesh and Value added (in %) of Fiji?
Your answer should be compact. -12.95. In the year 1976, what is the difference between the Value added (in %) of Bangladesh and Value added (in %) of Philippines?
Ensure brevity in your answer.  -20.91. In the year 1976, what is the difference between the Value added (in %) of Bangladesh and Value added (in %) of Somalia?
Offer a terse response. -16.44. In the year 1976, what is the difference between the Value added (in %) of Fiji and Value added (in %) of Philippines?
Your answer should be very brief. -7.97. In the year 1976, what is the difference between the Value added (in %) in Fiji and Value added (in %) in Somalia?
Make the answer very short. -3.5. In the year 1976, what is the difference between the Value added (in %) in Philippines and Value added (in %) in Somalia?
Provide a short and direct response. 4.47. In the year 1977, what is the difference between the Value added (in %) of Bangladesh and Value added (in %) of Fiji?
Give a very brief answer. -7.67. In the year 1977, what is the difference between the Value added (in %) in Bangladesh and Value added (in %) in Philippines?
Your answer should be very brief. -18.96. In the year 1977, what is the difference between the Value added (in %) in Bangladesh and Value added (in %) in Somalia?
Offer a terse response. -14.38. In the year 1977, what is the difference between the Value added (in %) in Fiji and Value added (in %) in Philippines?
Keep it short and to the point. -11.28. In the year 1977, what is the difference between the Value added (in %) of Fiji and Value added (in %) of Somalia?
Provide a short and direct response. -6.71. In the year 1977, what is the difference between the Value added (in %) in Philippines and Value added (in %) in Somalia?
Make the answer very short. 4.57. In the year 1978, what is the difference between the Value added (in %) in Bangladesh and Value added (in %) in Fiji?
Provide a short and direct response. -13.1. In the year 1978, what is the difference between the Value added (in %) in Bangladesh and Value added (in %) in Philippines?
Ensure brevity in your answer.  -21.92. In the year 1978, what is the difference between the Value added (in %) of Bangladesh and Value added (in %) of Somalia?
Your answer should be compact. -11.42. In the year 1978, what is the difference between the Value added (in %) of Fiji and Value added (in %) of Philippines?
Make the answer very short. -8.82. In the year 1978, what is the difference between the Value added (in %) in Fiji and Value added (in %) in Somalia?
Your answer should be very brief. 1.68. In the year 1978, what is the difference between the Value added (in %) of Philippines and Value added (in %) of Somalia?
Make the answer very short. 10.5. In the year 1979, what is the difference between the Value added (in %) of Bangladesh and Value added (in %) of Fiji?
Your answer should be compact. -9.63. In the year 1979, what is the difference between the Value added (in %) of Bangladesh and Value added (in %) of Philippines?
Your response must be concise. -15.96. In the year 1979, what is the difference between the Value added (in %) in Bangladesh and Value added (in %) in Somalia?
Offer a very short reply. -16.84. In the year 1979, what is the difference between the Value added (in %) of Fiji and Value added (in %) of Philippines?
Your answer should be very brief. -6.33. In the year 1979, what is the difference between the Value added (in %) of Fiji and Value added (in %) of Somalia?
Make the answer very short. -7.21. In the year 1979, what is the difference between the Value added (in %) of Philippines and Value added (in %) of Somalia?
Offer a terse response. -0.87. In the year 1986, what is the difference between the Value added (in %) of Bangladesh and Value added (in %) of Fiji?
Provide a short and direct response. -6.03. In the year 1986, what is the difference between the Value added (in %) in Bangladesh and Value added (in %) in Philippines?
Your answer should be very brief. -18.82. In the year 1986, what is the difference between the Value added (in %) of Bangladesh and Value added (in %) of Somalia?
Provide a short and direct response. 6.09. In the year 1986, what is the difference between the Value added (in %) of Fiji and Value added (in %) of Philippines?
Provide a short and direct response. -12.78. In the year 1986, what is the difference between the Value added (in %) of Fiji and Value added (in %) of Somalia?
Give a very brief answer. 12.12. In the year 1986, what is the difference between the Value added (in %) of Philippines and Value added (in %) of Somalia?
Provide a succinct answer. 24.9. What is the ratio of the Value added (in %) in Bangladesh in 1973 to that in 1974?
Offer a very short reply. 1.02. What is the ratio of the Value added (in %) in Fiji in 1973 to that in 1974?
Your answer should be very brief. 1.33. What is the ratio of the Value added (in %) in Philippines in 1973 to that in 1974?
Offer a terse response. 1.09. What is the ratio of the Value added (in %) of Somalia in 1973 to that in 1974?
Provide a short and direct response. 0.49. What is the ratio of the Value added (in %) of Bangladesh in 1973 to that in 1975?
Your answer should be very brief. 0.72. What is the ratio of the Value added (in %) in Fiji in 1973 to that in 1975?
Provide a short and direct response. 1.45. What is the ratio of the Value added (in %) of Philippines in 1973 to that in 1975?
Give a very brief answer. 1.21. What is the ratio of the Value added (in %) of Somalia in 1973 to that in 1975?
Your response must be concise. 0.51. What is the ratio of the Value added (in %) in Bangladesh in 1973 to that in 1976?
Your answer should be very brief. 0.68. What is the ratio of the Value added (in %) of Fiji in 1973 to that in 1976?
Provide a short and direct response. 1.13. What is the ratio of the Value added (in %) in Somalia in 1973 to that in 1976?
Your answer should be compact. 0.53. What is the ratio of the Value added (in %) of Bangladesh in 1973 to that in 1977?
Ensure brevity in your answer.  0.59. What is the ratio of the Value added (in %) of Fiji in 1973 to that in 1977?
Your answer should be very brief. 1.27. What is the ratio of the Value added (in %) of Philippines in 1973 to that in 1977?
Your answer should be compact. 0.99. What is the ratio of the Value added (in %) in Somalia in 1973 to that in 1977?
Your response must be concise. 0.53. What is the ratio of the Value added (in %) in Bangladesh in 1973 to that in 1978?
Ensure brevity in your answer.  0.65. What is the ratio of the Value added (in %) in Fiji in 1973 to that in 1978?
Provide a short and direct response. 1.11. What is the ratio of the Value added (in %) of Somalia in 1973 to that in 1978?
Keep it short and to the point. 0.62. What is the ratio of the Value added (in %) of Bangladesh in 1973 to that in 1979?
Your response must be concise. 0.61. What is the ratio of the Value added (in %) in Fiji in 1973 to that in 1979?
Your answer should be very brief. 1.2. What is the ratio of the Value added (in %) of Philippines in 1973 to that in 1979?
Give a very brief answer. 1.1. What is the ratio of the Value added (in %) of Somalia in 1973 to that in 1979?
Give a very brief answer. 0.5. What is the ratio of the Value added (in %) in Bangladesh in 1973 to that in 1986?
Your response must be concise. 0.54. What is the ratio of the Value added (in %) of Fiji in 1973 to that in 1986?
Ensure brevity in your answer.  1.27. What is the ratio of the Value added (in %) of Philippines in 1973 to that in 1986?
Ensure brevity in your answer.  0.95. What is the ratio of the Value added (in %) in Somalia in 1973 to that in 1986?
Your response must be concise. 1.28. What is the ratio of the Value added (in %) in Bangladesh in 1974 to that in 1975?
Give a very brief answer. 0.71. What is the ratio of the Value added (in %) of Fiji in 1974 to that in 1975?
Provide a short and direct response. 1.09. What is the ratio of the Value added (in %) in Philippines in 1974 to that in 1975?
Ensure brevity in your answer.  1.1. What is the ratio of the Value added (in %) of Somalia in 1974 to that in 1975?
Keep it short and to the point. 1.04. What is the ratio of the Value added (in %) in Bangladesh in 1974 to that in 1976?
Your response must be concise. 0.66. What is the ratio of the Value added (in %) in Fiji in 1974 to that in 1976?
Give a very brief answer. 0.85. What is the ratio of the Value added (in %) in Philippines in 1974 to that in 1976?
Give a very brief answer. 0.91. What is the ratio of the Value added (in %) of Somalia in 1974 to that in 1976?
Offer a very short reply. 1.09. What is the ratio of the Value added (in %) in Bangladesh in 1974 to that in 1977?
Your answer should be very brief. 0.58. What is the ratio of the Value added (in %) of Philippines in 1974 to that in 1977?
Your response must be concise. 0.91. What is the ratio of the Value added (in %) in Somalia in 1974 to that in 1977?
Keep it short and to the point. 1.08. What is the ratio of the Value added (in %) of Bangladesh in 1974 to that in 1978?
Offer a terse response. 0.64. What is the ratio of the Value added (in %) of Fiji in 1974 to that in 1978?
Offer a very short reply. 0.84. What is the ratio of the Value added (in %) in Philippines in 1974 to that in 1978?
Offer a terse response. 0.88. What is the ratio of the Value added (in %) of Somalia in 1974 to that in 1978?
Your answer should be compact. 1.26. What is the ratio of the Value added (in %) of Bangladesh in 1974 to that in 1979?
Your response must be concise. 0.59. What is the ratio of the Value added (in %) of Fiji in 1974 to that in 1979?
Offer a terse response. 0.9. What is the ratio of the Value added (in %) of Philippines in 1974 to that in 1979?
Offer a very short reply. 1. What is the ratio of the Value added (in %) of Somalia in 1974 to that in 1979?
Provide a succinct answer. 1.02. What is the ratio of the Value added (in %) in Bangladesh in 1974 to that in 1986?
Offer a terse response. 0.53. What is the ratio of the Value added (in %) of Fiji in 1974 to that in 1986?
Ensure brevity in your answer.  0.96. What is the ratio of the Value added (in %) of Philippines in 1974 to that in 1986?
Your response must be concise. 0.87. What is the ratio of the Value added (in %) of Somalia in 1974 to that in 1986?
Ensure brevity in your answer.  2.61. What is the ratio of the Value added (in %) of Bangladesh in 1975 to that in 1976?
Ensure brevity in your answer.  0.93. What is the ratio of the Value added (in %) in Fiji in 1975 to that in 1976?
Your answer should be compact. 0.78. What is the ratio of the Value added (in %) in Philippines in 1975 to that in 1976?
Your response must be concise. 0.83. What is the ratio of the Value added (in %) in Somalia in 1975 to that in 1976?
Keep it short and to the point. 1.05. What is the ratio of the Value added (in %) of Bangladesh in 1975 to that in 1977?
Keep it short and to the point. 0.82. What is the ratio of the Value added (in %) in Fiji in 1975 to that in 1977?
Make the answer very short. 0.88. What is the ratio of the Value added (in %) of Philippines in 1975 to that in 1977?
Make the answer very short. 0.82. What is the ratio of the Value added (in %) in Somalia in 1975 to that in 1977?
Your answer should be compact. 1.04. What is the ratio of the Value added (in %) of Bangladesh in 1975 to that in 1978?
Provide a succinct answer. 0.9. What is the ratio of the Value added (in %) in Fiji in 1975 to that in 1978?
Ensure brevity in your answer.  0.76. What is the ratio of the Value added (in %) in Philippines in 1975 to that in 1978?
Your answer should be compact. 0.8. What is the ratio of the Value added (in %) of Somalia in 1975 to that in 1978?
Your response must be concise. 1.22. What is the ratio of the Value added (in %) in Bangladesh in 1975 to that in 1979?
Give a very brief answer. 0.84. What is the ratio of the Value added (in %) in Fiji in 1975 to that in 1979?
Give a very brief answer. 0.82. What is the ratio of the Value added (in %) in Philippines in 1975 to that in 1979?
Your answer should be very brief. 0.91. What is the ratio of the Value added (in %) in Somalia in 1975 to that in 1979?
Offer a terse response. 0.98. What is the ratio of the Value added (in %) of Bangladesh in 1975 to that in 1986?
Ensure brevity in your answer.  0.75. What is the ratio of the Value added (in %) in Fiji in 1975 to that in 1986?
Ensure brevity in your answer.  0.87. What is the ratio of the Value added (in %) in Philippines in 1975 to that in 1986?
Make the answer very short. 0.79. What is the ratio of the Value added (in %) in Somalia in 1975 to that in 1986?
Your answer should be very brief. 2.51. What is the ratio of the Value added (in %) in Bangladesh in 1976 to that in 1977?
Ensure brevity in your answer.  0.88. What is the ratio of the Value added (in %) in Fiji in 1976 to that in 1977?
Your answer should be compact. 1.12. What is the ratio of the Value added (in %) of Somalia in 1976 to that in 1977?
Give a very brief answer. 1. What is the ratio of the Value added (in %) in Bangladesh in 1976 to that in 1978?
Provide a succinct answer. 0.97. What is the ratio of the Value added (in %) in Fiji in 1976 to that in 1978?
Provide a succinct answer. 0.98. What is the ratio of the Value added (in %) of Philippines in 1976 to that in 1978?
Offer a terse response. 0.96. What is the ratio of the Value added (in %) of Somalia in 1976 to that in 1978?
Offer a terse response. 1.16. What is the ratio of the Value added (in %) in Bangladesh in 1976 to that in 1979?
Your answer should be compact. 0.9. What is the ratio of the Value added (in %) in Fiji in 1976 to that in 1979?
Provide a short and direct response. 1.06. What is the ratio of the Value added (in %) of Philippines in 1976 to that in 1979?
Your response must be concise. 1.09. What is the ratio of the Value added (in %) in Somalia in 1976 to that in 1979?
Offer a very short reply. 0.94. What is the ratio of the Value added (in %) of Bangladesh in 1976 to that in 1986?
Your answer should be compact. 0.8. What is the ratio of the Value added (in %) of Fiji in 1976 to that in 1986?
Offer a terse response. 1.12. What is the ratio of the Value added (in %) of Philippines in 1976 to that in 1986?
Your answer should be very brief. 0.95. What is the ratio of the Value added (in %) of Somalia in 1976 to that in 1986?
Provide a short and direct response. 2.4. What is the ratio of the Value added (in %) of Bangladesh in 1977 to that in 1978?
Offer a terse response. 1.1. What is the ratio of the Value added (in %) of Fiji in 1977 to that in 1978?
Your answer should be compact. 0.87. What is the ratio of the Value added (in %) of Philippines in 1977 to that in 1978?
Provide a short and direct response. 0.97. What is the ratio of the Value added (in %) in Somalia in 1977 to that in 1978?
Offer a terse response. 1.17. What is the ratio of the Value added (in %) in Bangladesh in 1977 to that in 1979?
Your response must be concise. 1.02. What is the ratio of the Value added (in %) in Fiji in 1977 to that in 1979?
Keep it short and to the point. 0.94. What is the ratio of the Value added (in %) in Philippines in 1977 to that in 1979?
Your answer should be compact. 1.1. What is the ratio of the Value added (in %) in Somalia in 1977 to that in 1979?
Offer a very short reply. 0.94. What is the ratio of the Value added (in %) of Bangladesh in 1977 to that in 1986?
Your answer should be very brief. 0.91. What is the ratio of the Value added (in %) in Philippines in 1977 to that in 1986?
Your answer should be very brief. 0.96. What is the ratio of the Value added (in %) in Somalia in 1977 to that in 1986?
Offer a terse response. 2.41. What is the ratio of the Value added (in %) in Bangladesh in 1978 to that in 1979?
Give a very brief answer. 0.92. What is the ratio of the Value added (in %) of Fiji in 1978 to that in 1979?
Keep it short and to the point. 1.08. What is the ratio of the Value added (in %) in Philippines in 1978 to that in 1979?
Your answer should be compact. 1.14. What is the ratio of the Value added (in %) in Somalia in 1978 to that in 1979?
Keep it short and to the point. 0.8. What is the ratio of the Value added (in %) of Bangladesh in 1978 to that in 1986?
Your answer should be compact. 0.83. What is the ratio of the Value added (in %) in Fiji in 1978 to that in 1986?
Your response must be concise. 1.15. What is the ratio of the Value added (in %) in Somalia in 1978 to that in 1986?
Ensure brevity in your answer.  2.06. What is the ratio of the Value added (in %) in Bangladesh in 1979 to that in 1986?
Your answer should be compact. 0.89. What is the ratio of the Value added (in %) in Fiji in 1979 to that in 1986?
Ensure brevity in your answer.  1.06. What is the ratio of the Value added (in %) of Philippines in 1979 to that in 1986?
Make the answer very short. 0.87. What is the ratio of the Value added (in %) of Somalia in 1979 to that in 1986?
Keep it short and to the point. 2.57. What is the difference between the highest and the second highest Value added (in %) in Bangladesh?
Give a very brief answer. 1.7. What is the difference between the highest and the second highest Value added (in %) of Fiji?
Make the answer very short. 3.14. What is the difference between the highest and the second highest Value added (in %) in Philippines?
Your answer should be very brief. 0.27. What is the difference between the highest and the second highest Value added (in %) of Somalia?
Your answer should be compact. 0.55. What is the difference between the highest and the lowest Value added (in %) in Bangladesh?
Your answer should be very brief. 9.15. What is the difference between the highest and the lowest Value added (in %) of Fiji?
Keep it short and to the point. 10.03. What is the difference between the highest and the lowest Value added (in %) of Philippines?
Provide a short and direct response. 7.99. What is the difference between the highest and the lowest Value added (in %) of Somalia?
Offer a very short reply. 21.4. 